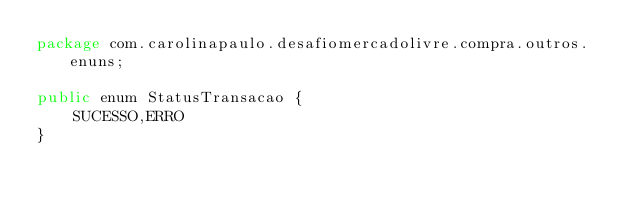<code> <loc_0><loc_0><loc_500><loc_500><_Java_>package com.carolinapaulo.desafiomercadolivre.compra.outros.enuns;

public enum StatusTransacao {
    SUCESSO,ERRO
}
</code> 